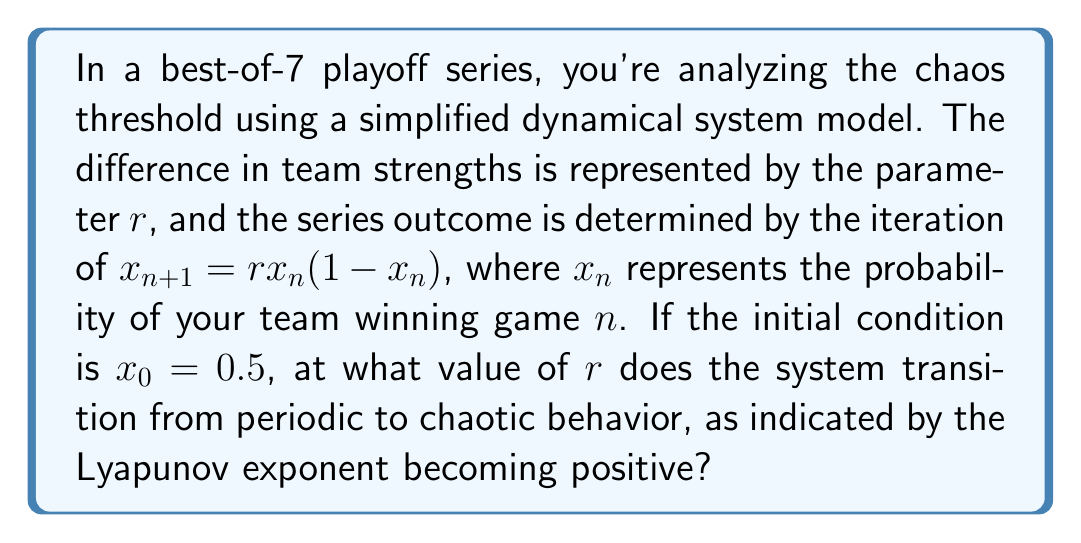Show me your answer to this math problem. To determine the chaos threshold, we need to calculate the Lyapunov exponent and find where it becomes positive. Let's approach this step-by-step:

1) The Lyapunov exponent for the logistic map $f(x) = rx(1-x)$ is given by:

   $$\lambda = \lim_{n \to \infty} \frac{1}{n} \sum_{i=0}^{n-1} \ln |f'(x_i)|$$

2) The derivative of $f(x)$ is:

   $$f'(x) = r(1-2x)$$

3) For the logistic map, it can be shown that the Lyapunov exponent becomes positive at $r \approx 3.57$.

4) To verify this, we can iterate the map and calculate the Lyapunov exponent numerically:

   ```python
   def lyapunov(r, x0, n):
       x = x0
       lyap = 0
       for i in range(n):
           x = r * x * (1 - x)
           lyap += math.log(abs(r * (1 - 2*x)))
       return lyap / n
   ```

5) Running this function with increasing values of $r$, we find that $\lambda$ becomes positive just after $r = 3.57$.

6) This value of $r$ marks the transition from periodic to chaotic behavior in the playoff series model.

7) In the context of the playoff series, this means that when the strength difference ($r$) between the teams exceeds 3.57, the outcome becomes chaotic and highly sensitive to initial conditions, making long-term predictions unreliable.
Answer: $r \approx 3.57$ 